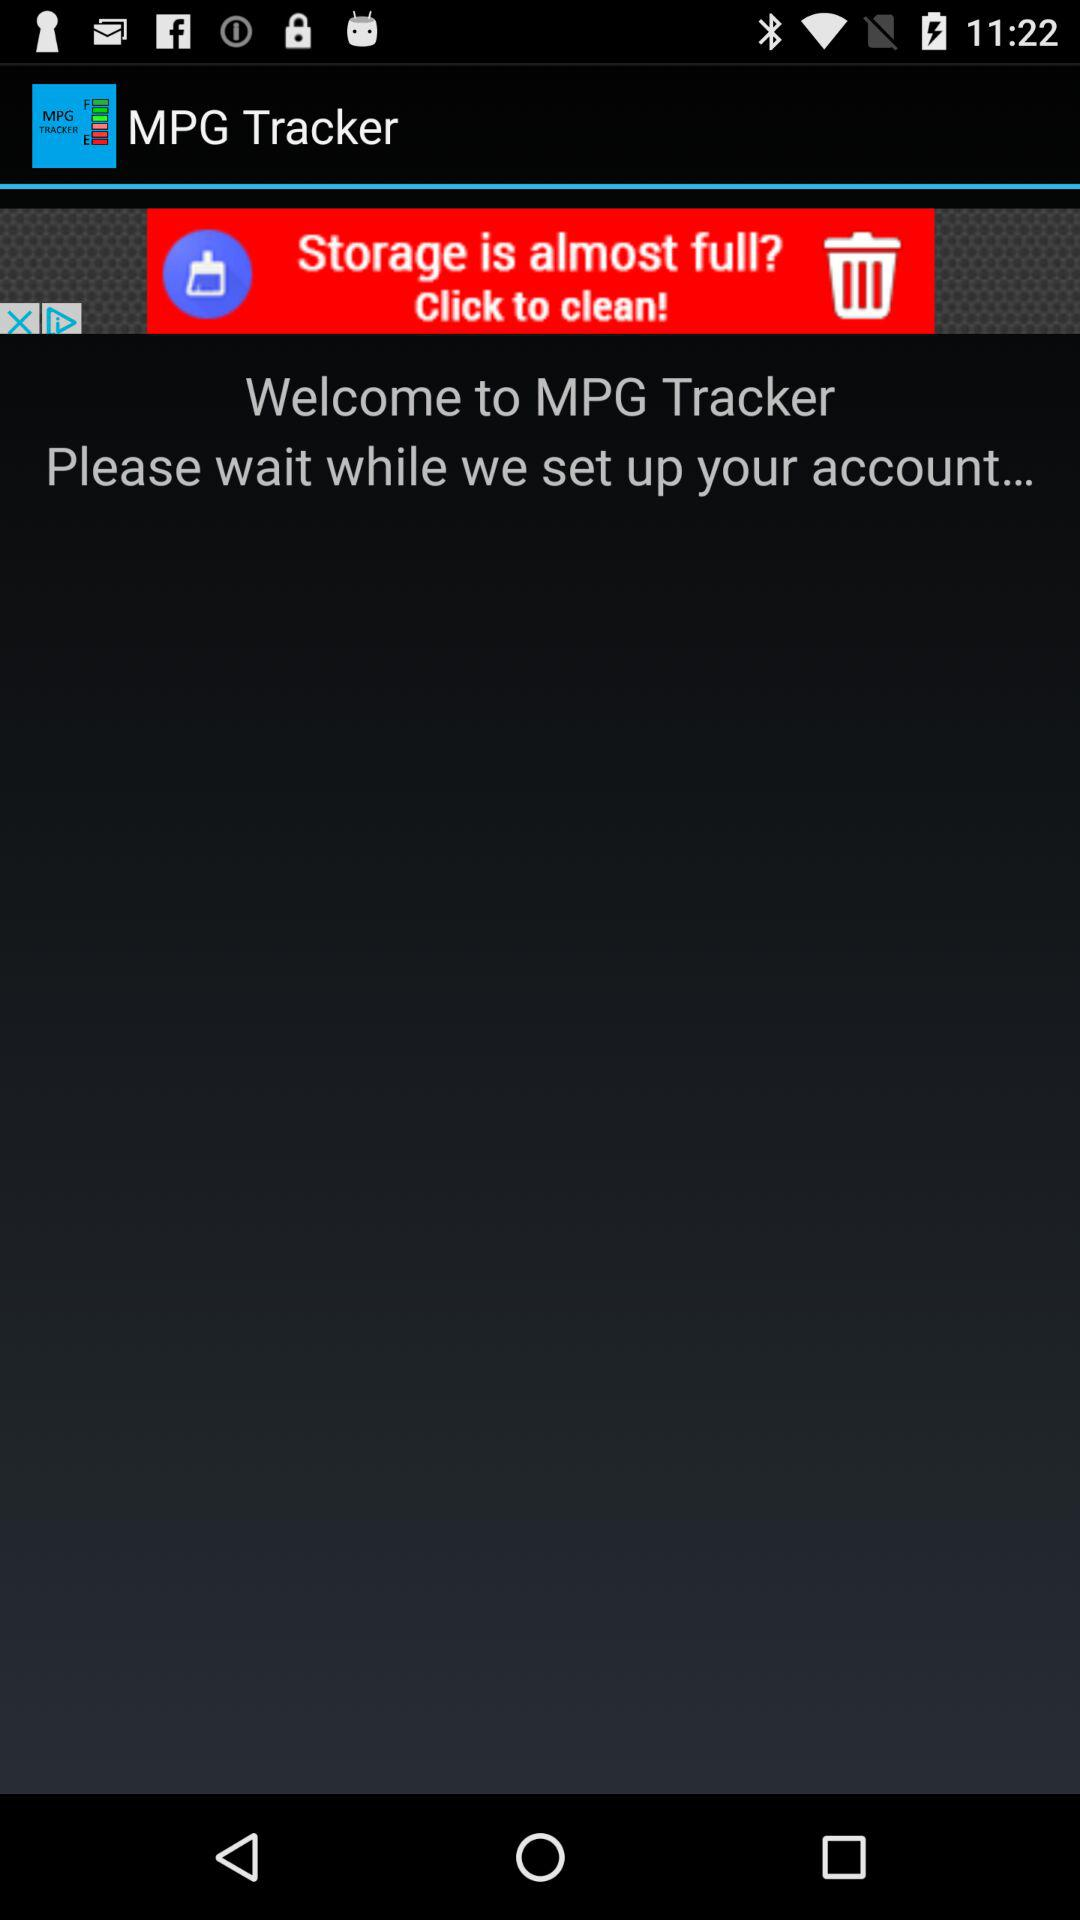What is the name of the application? The name of the application is "MPG Tracker". 